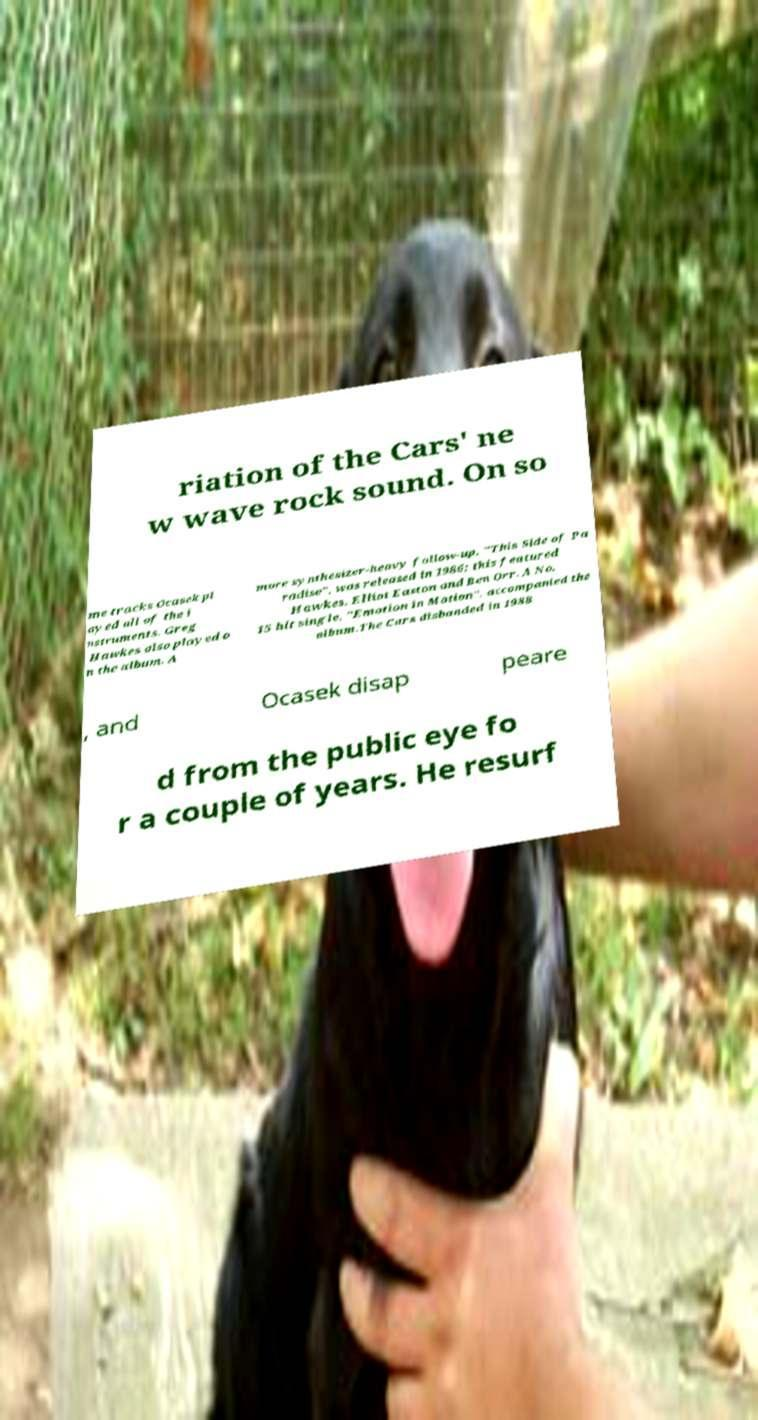There's text embedded in this image that I need extracted. Can you transcribe it verbatim? riation of the Cars' ne w wave rock sound. On so me tracks Ocasek pl ayed all of the i nstruments. Greg Hawkes also played o n the album. A more synthesizer-heavy follow-up, "This Side of Pa radise", was released in 1986; this featured Hawkes, Elliot Easton and Ben Orr. A No. 15 hit single, "Emotion in Motion", accompanied the album.The Cars disbanded in 1988 , and Ocasek disap peare d from the public eye fo r a couple of years. He resurf 